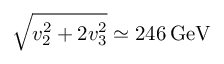Convert formula to latex. <formula><loc_0><loc_0><loc_500><loc_500>\sqrt { v _ { 2 } ^ { 2 } + 2 v _ { 3 } ^ { 2 } } \simeq 2 4 6 \, G e V</formula> 